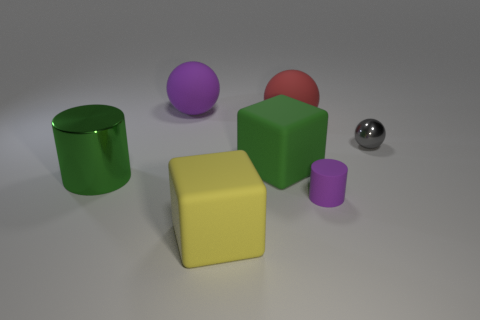There is a small thing that is on the right side of the purple rubber object in front of the large green cylinder; what is its material?
Make the answer very short. Metal. What number of objects are either tiny purple cylinders to the left of the gray sphere or small objects on the left side of the gray metallic sphere?
Ensure brevity in your answer.  1. There is a purple rubber thing that is behind the cylinder that is behind the matte object to the right of the red object; how big is it?
Give a very brief answer. Large. Are there the same number of green rubber cubes left of the big green metal cylinder and tiny gray things?
Your answer should be compact. No. Are there any other things that have the same shape as the small purple thing?
Ensure brevity in your answer.  Yes. There is a large purple object; does it have the same shape as the metallic thing to the right of the big purple object?
Offer a terse response. Yes. The gray metallic object that is the same shape as the large purple matte object is what size?
Keep it short and to the point. Small. What number of other things are there of the same material as the gray thing
Your answer should be very brief. 1. What is the material of the small purple cylinder?
Your answer should be compact. Rubber. Is the color of the block that is in front of the green cylinder the same as the small object to the left of the small ball?
Make the answer very short. No. 